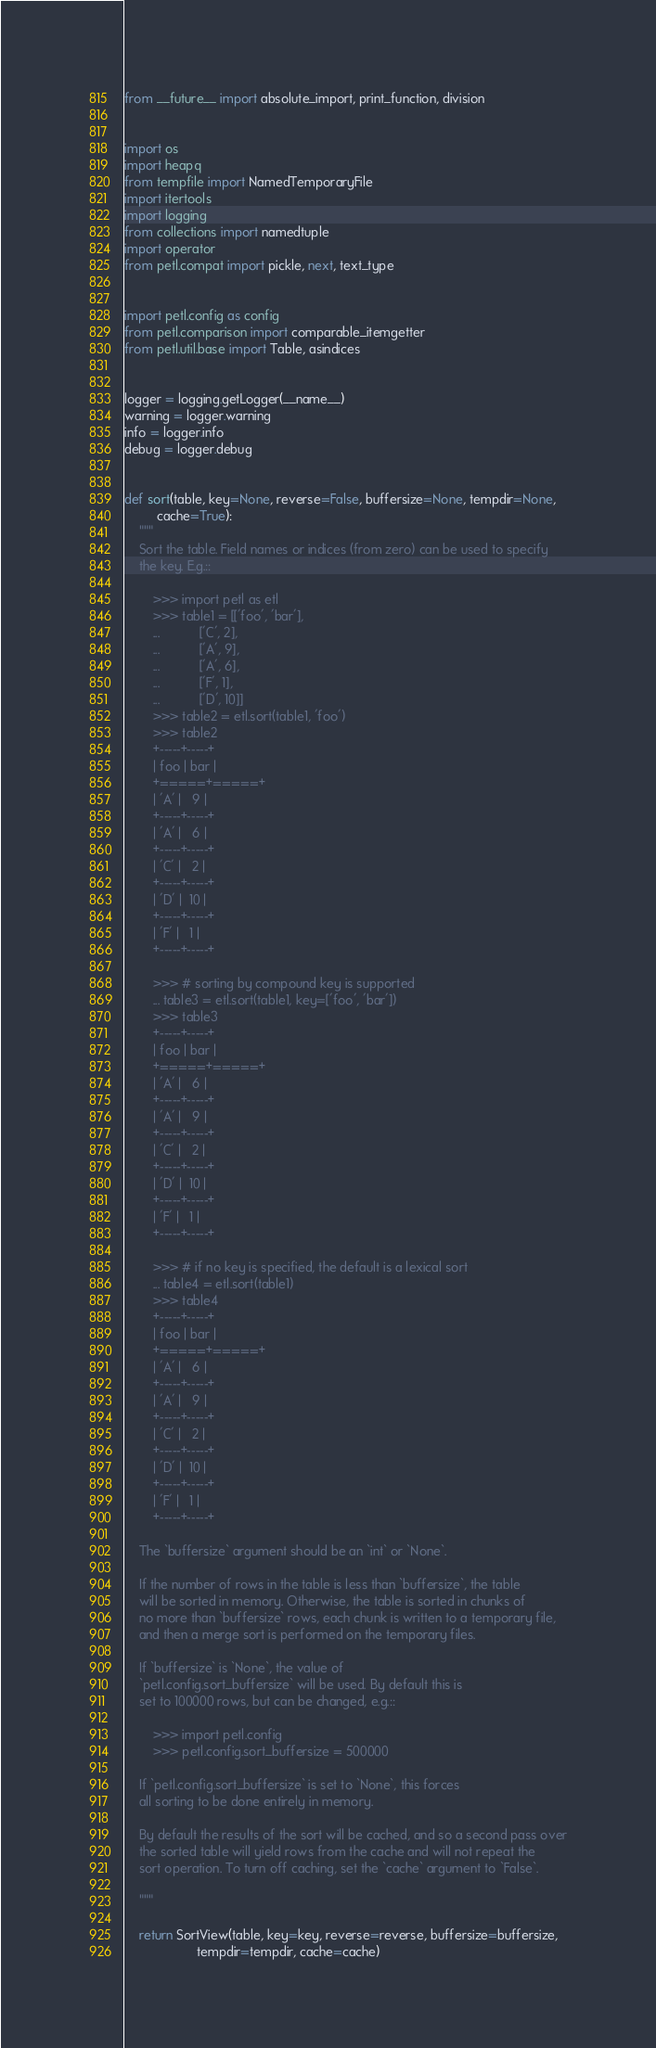Convert code to text. <code><loc_0><loc_0><loc_500><loc_500><_Python_>from __future__ import absolute_import, print_function, division


import os
import heapq
from tempfile import NamedTemporaryFile
import itertools
import logging
from collections import namedtuple
import operator
from petl.compat import pickle, next, text_type


import petl.config as config
from petl.comparison import comparable_itemgetter
from petl.util.base import Table, asindices


logger = logging.getLogger(__name__)
warning = logger.warning
info = logger.info
debug = logger.debug


def sort(table, key=None, reverse=False, buffersize=None, tempdir=None,
         cache=True):
    """
    Sort the table. Field names or indices (from zero) can be used to specify
    the key. E.g.::

        >>> import petl as etl
        >>> table1 = [['foo', 'bar'],
        ...           ['C', 2],
        ...           ['A', 9],
        ...           ['A', 6],
        ...           ['F', 1],
        ...           ['D', 10]]
        >>> table2 = etl.sort(table1, 'foo')
        >>> table2
        +-----+-----+
        | foo | bar |
        +=====+=====+
        | 'A' |   9 |
        +-----+-----+
        | 'A' |   6 |
        +-----+-----+
        | 'C' |   2 |
        +-----+-----+
        | 'D' |  10 |
        +-----+-----+
        | 'F' |   1 |
        +-----+-----+

        >>> # sorting by compound key is supported
        ... table3 = etl.sort(table1, key=['foo', 'bar'])
        >>> table3
        +-----+-----+
        | foo | bar |
        +=====+=====+
        | 'A' |   6 |
        +-----+-----+
        | 'A' |   9 |
        +-----+-----+
        | 'C' |   2 |
        +-----+-----+
        | 'D' |  10 |
        +-----+-----+
        | 'F' |   1 |
        +-----+-----+

        >>> # if no key is specified, the default is a lexical sort
        ... table4 = etl.sort(table1)
        >>> table4
        +-----+-----+
        | foo | bar |
        +=====+=====+
        | 'A' |   6 |
        +-----+-----+
        | 'A' |   9 |
        +-----+-----+
        | 'C' |   2 |
        +-----+-----+
        | 'D' |  10 |
        +-----+-----+
        | 'F' |   1 |
        +-----+-----+

    The `buffersize` argument should be an `int` or `None`.

    If the number of rows in the table is less than `buffersize`, the table
    will be sorted in memory. Otherwise, the table is sorted in chunks of
    no more than `buffersize` rows, each chunk is written to a temporary file,
    and then a merge sort is performed on the temporary files.

    If `buffersize` is `None`, the value of
    `petl.config.sort_buffersize` will be used. By default this is
    set to 100000 rows, but can be changed, e.g.::

        >>> import petl.config
        >>> petl.config.sort_buffersize = 500000

    If `petl.config.sort_buffersize` is set to `None`, this forces
    all sorting to be done entirely in memory.

    By default the results of the sort will be cached, and so a second pass over
    the sorted table will yield rows from the cache and will not repeat the
    sort operation. To turn off caching, set the `cache` argument to `False`.

    """

    return SortView(table, key=key, reverse=reverse, buffersize=buffersize,
                    tempdir=tempdir, cache=cache)

</code> 